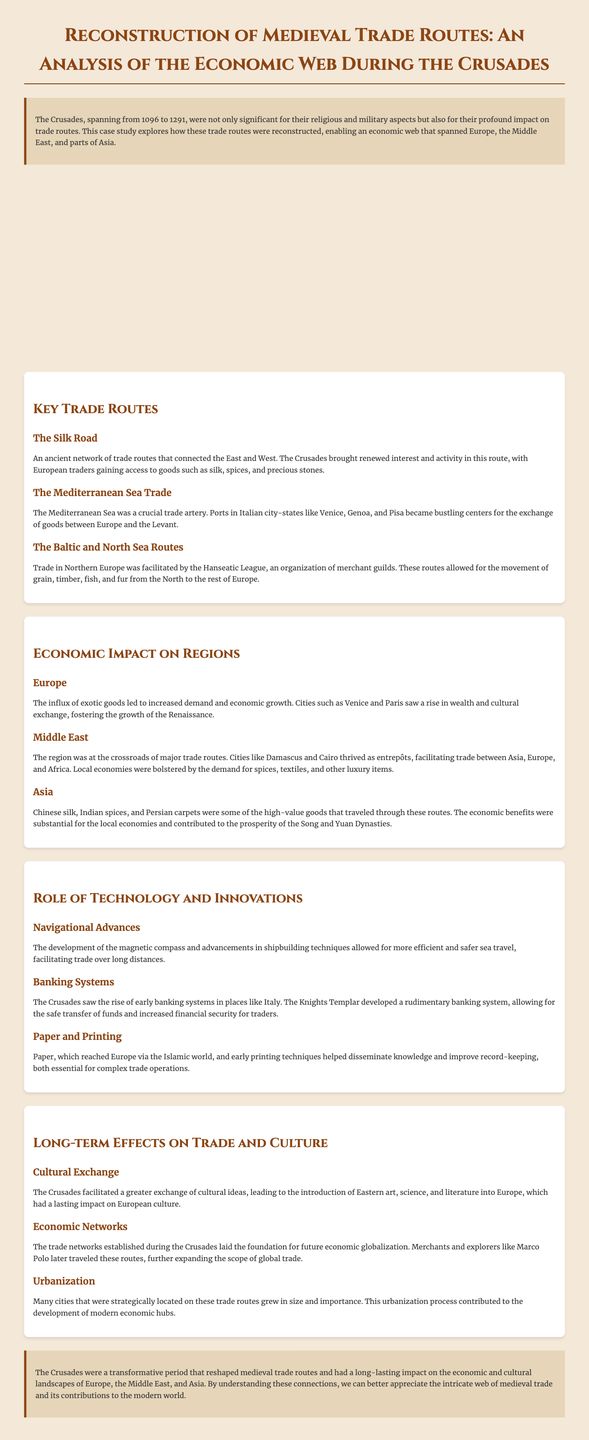What were the years of the Crusades? The document states the Crusades spanned from 1096 to 1291.
Answer: 1096 to 1291 What was a key trade route connecting the East and West? The case study mentions "The Silk Road" as an ancient network of trade routes.
Answer: The Silk Road Which city-states in Italy were mentioned as crucial for trade? The document highlights Venice, Genoa, and Pisa as bustling centers for the exchange of goods.
Answer: Venice, Genoa, and Pisa What major trade organization was mentioned in Northern Europe? The document references the Hanseatic League as an organization of merchant guilds.
Answer: Hanseatic League What impact did the Crusades have on cities like Venice and Paris? The case study explains that these cities saw a rise in wealth and cultural exchange.
Answer: Increased wealth and cultural exchange What is one innovation that improved sea travel during the Crusades? The document discusses the development of the magnetic compass as a navigational advance.
Answer: Magnetic compass Which luxury goods were traded from Asia through these routes? The document mentions Chinese silk, Indian spices, and Persian carpets as high-value goods.
Answer: Silk, spices, carpets What long-term effect did the Crusades have on urbanization? The case study states that many cities grew in size and importance due to their strategic locations.
Answer: Growth in size and importance What type of document is this? The structured analysis presented in the document indicates it is a case study focusing on a historical topic.
Answer: Case study 